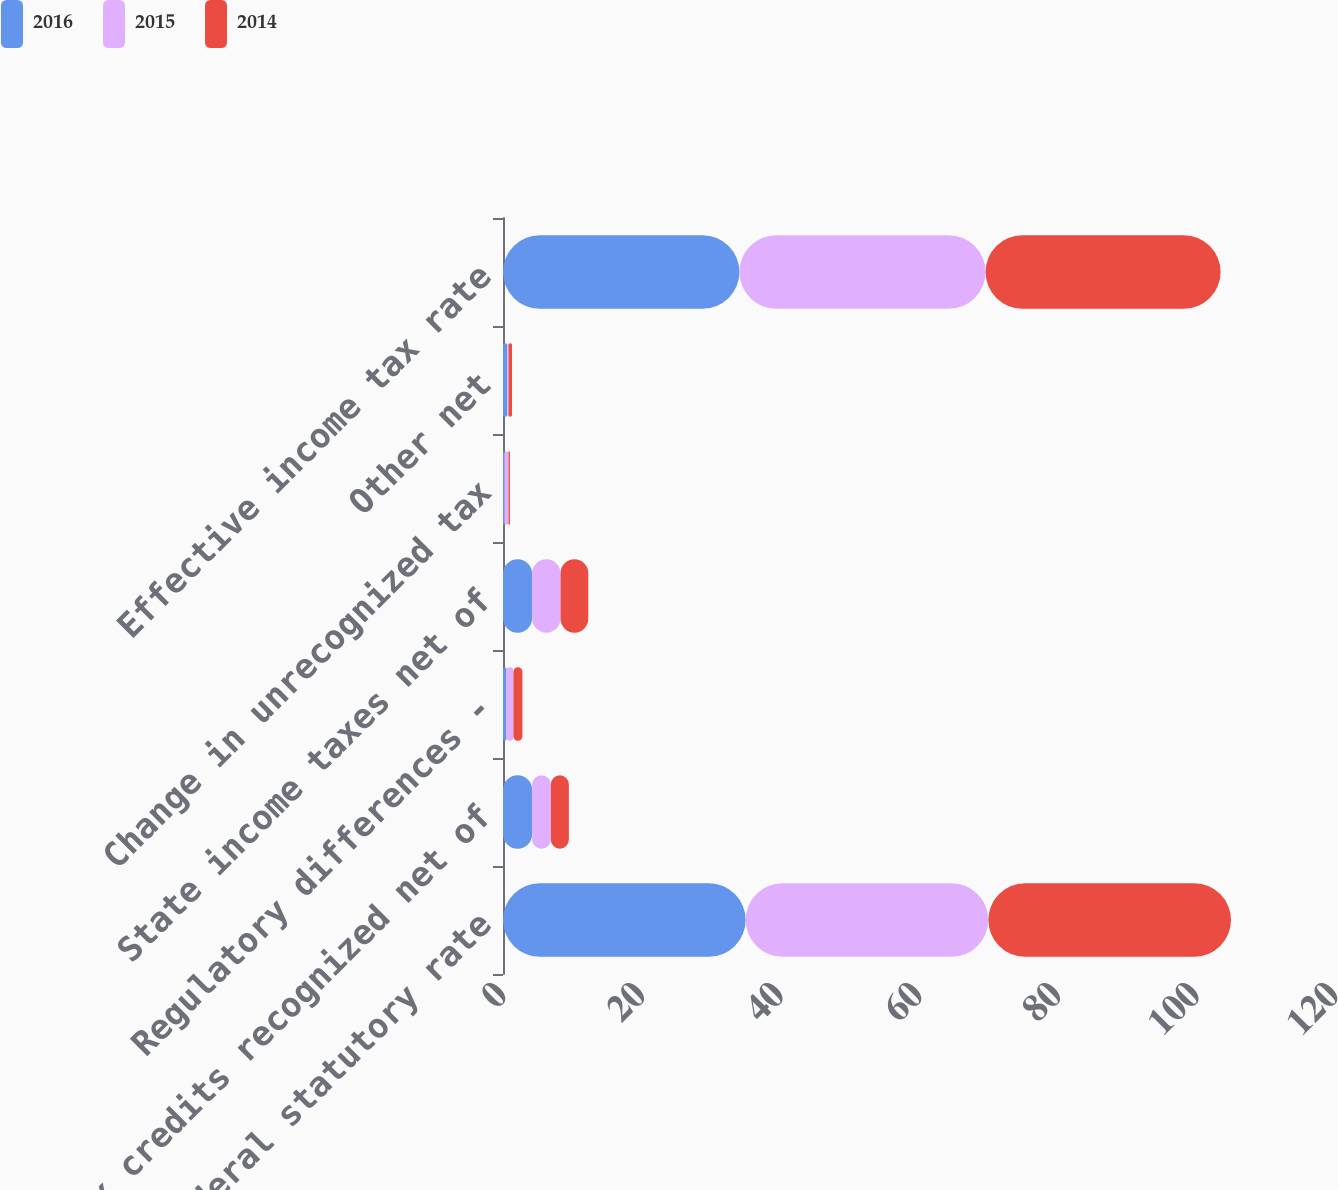Convert chart to OTSL. <chart><loc_0><loc_0><loc_500><loc_500><stacked_bar_chart><ecel><fcel>Federal statutory rate<fcel>Tax credits recognized net of<fcel>Regulatory differences -<fcel>State income taxes net of<fcel>Change in unrecognized tax<fcel>Other net<fcel>Effective income tax rate<nl><fcel>2016<fcel>35<fcel>4.2<fcel>0.5<fcel>4.2<fcel>0.2<fcel>0.6<fcel>34.1<nl><fcel>2015<fcel>35<fcel>2.7<fcel>1<fcel>4.1<fcel>0.6<fcel>0.2<fcel>35.5<nl><fcel>2014<fcel>35<fcel>2.6<fcel>1.3<fcel>4<fcel>0.2<fcel>0.5<fcel>33.9<nl></chart> 